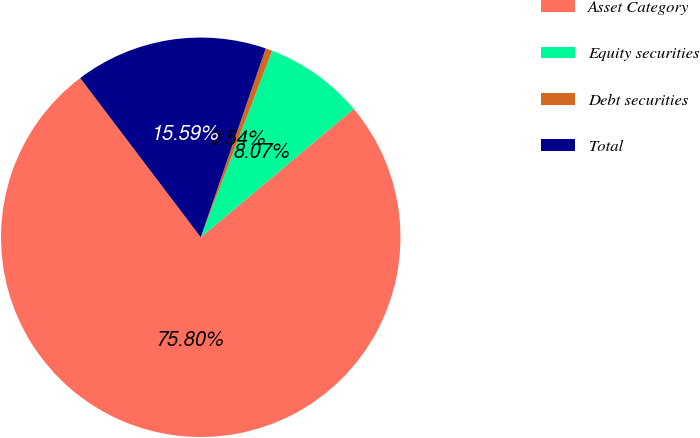<chart> <loc_0><loc_0><loc_500><loc_500><pie_chart><fcel>Asset Category<fcel>Equity securities<fcel>Debt securities<fcel>Total<nl><fcel>75.8%<fcel>8.07%<fcel>0.54%<fcel>15.59%<nl></chart> 